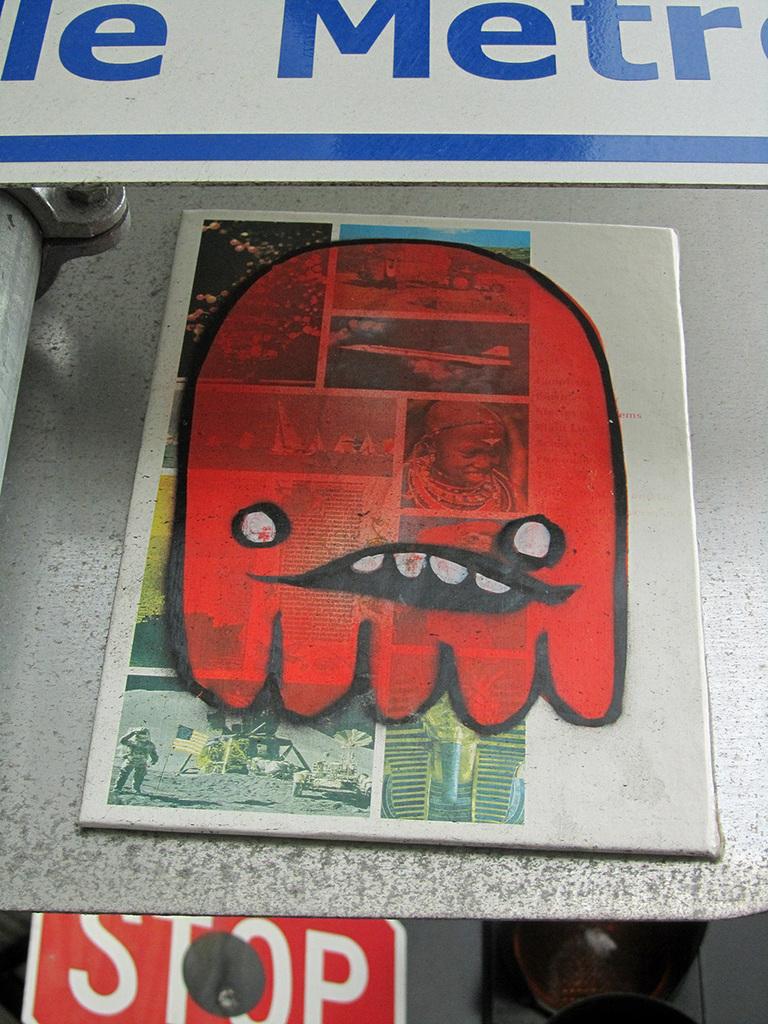What does the sign on the red background say?
Your answer should be compact. Stop. What is the capital letter on the sign above the red thing?
Provide a short and direct response. M. 